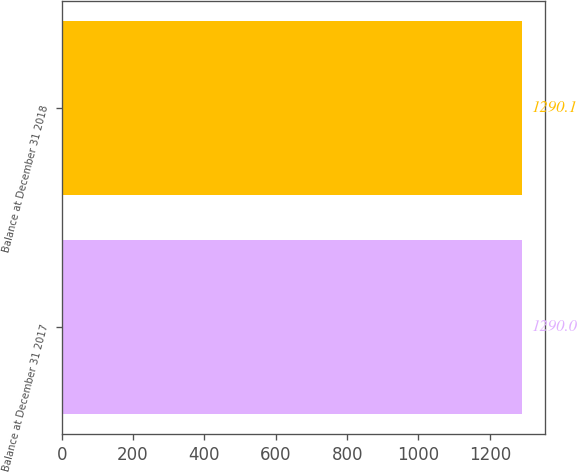<chart> <loc_0><loc_0><loc_500><loc_500><bar_chart><fcel>Balance at December 31 2017<fcel>Balance at December 31 2018<nl><fcel>1290<fcel>1290.1<nl></chart> 